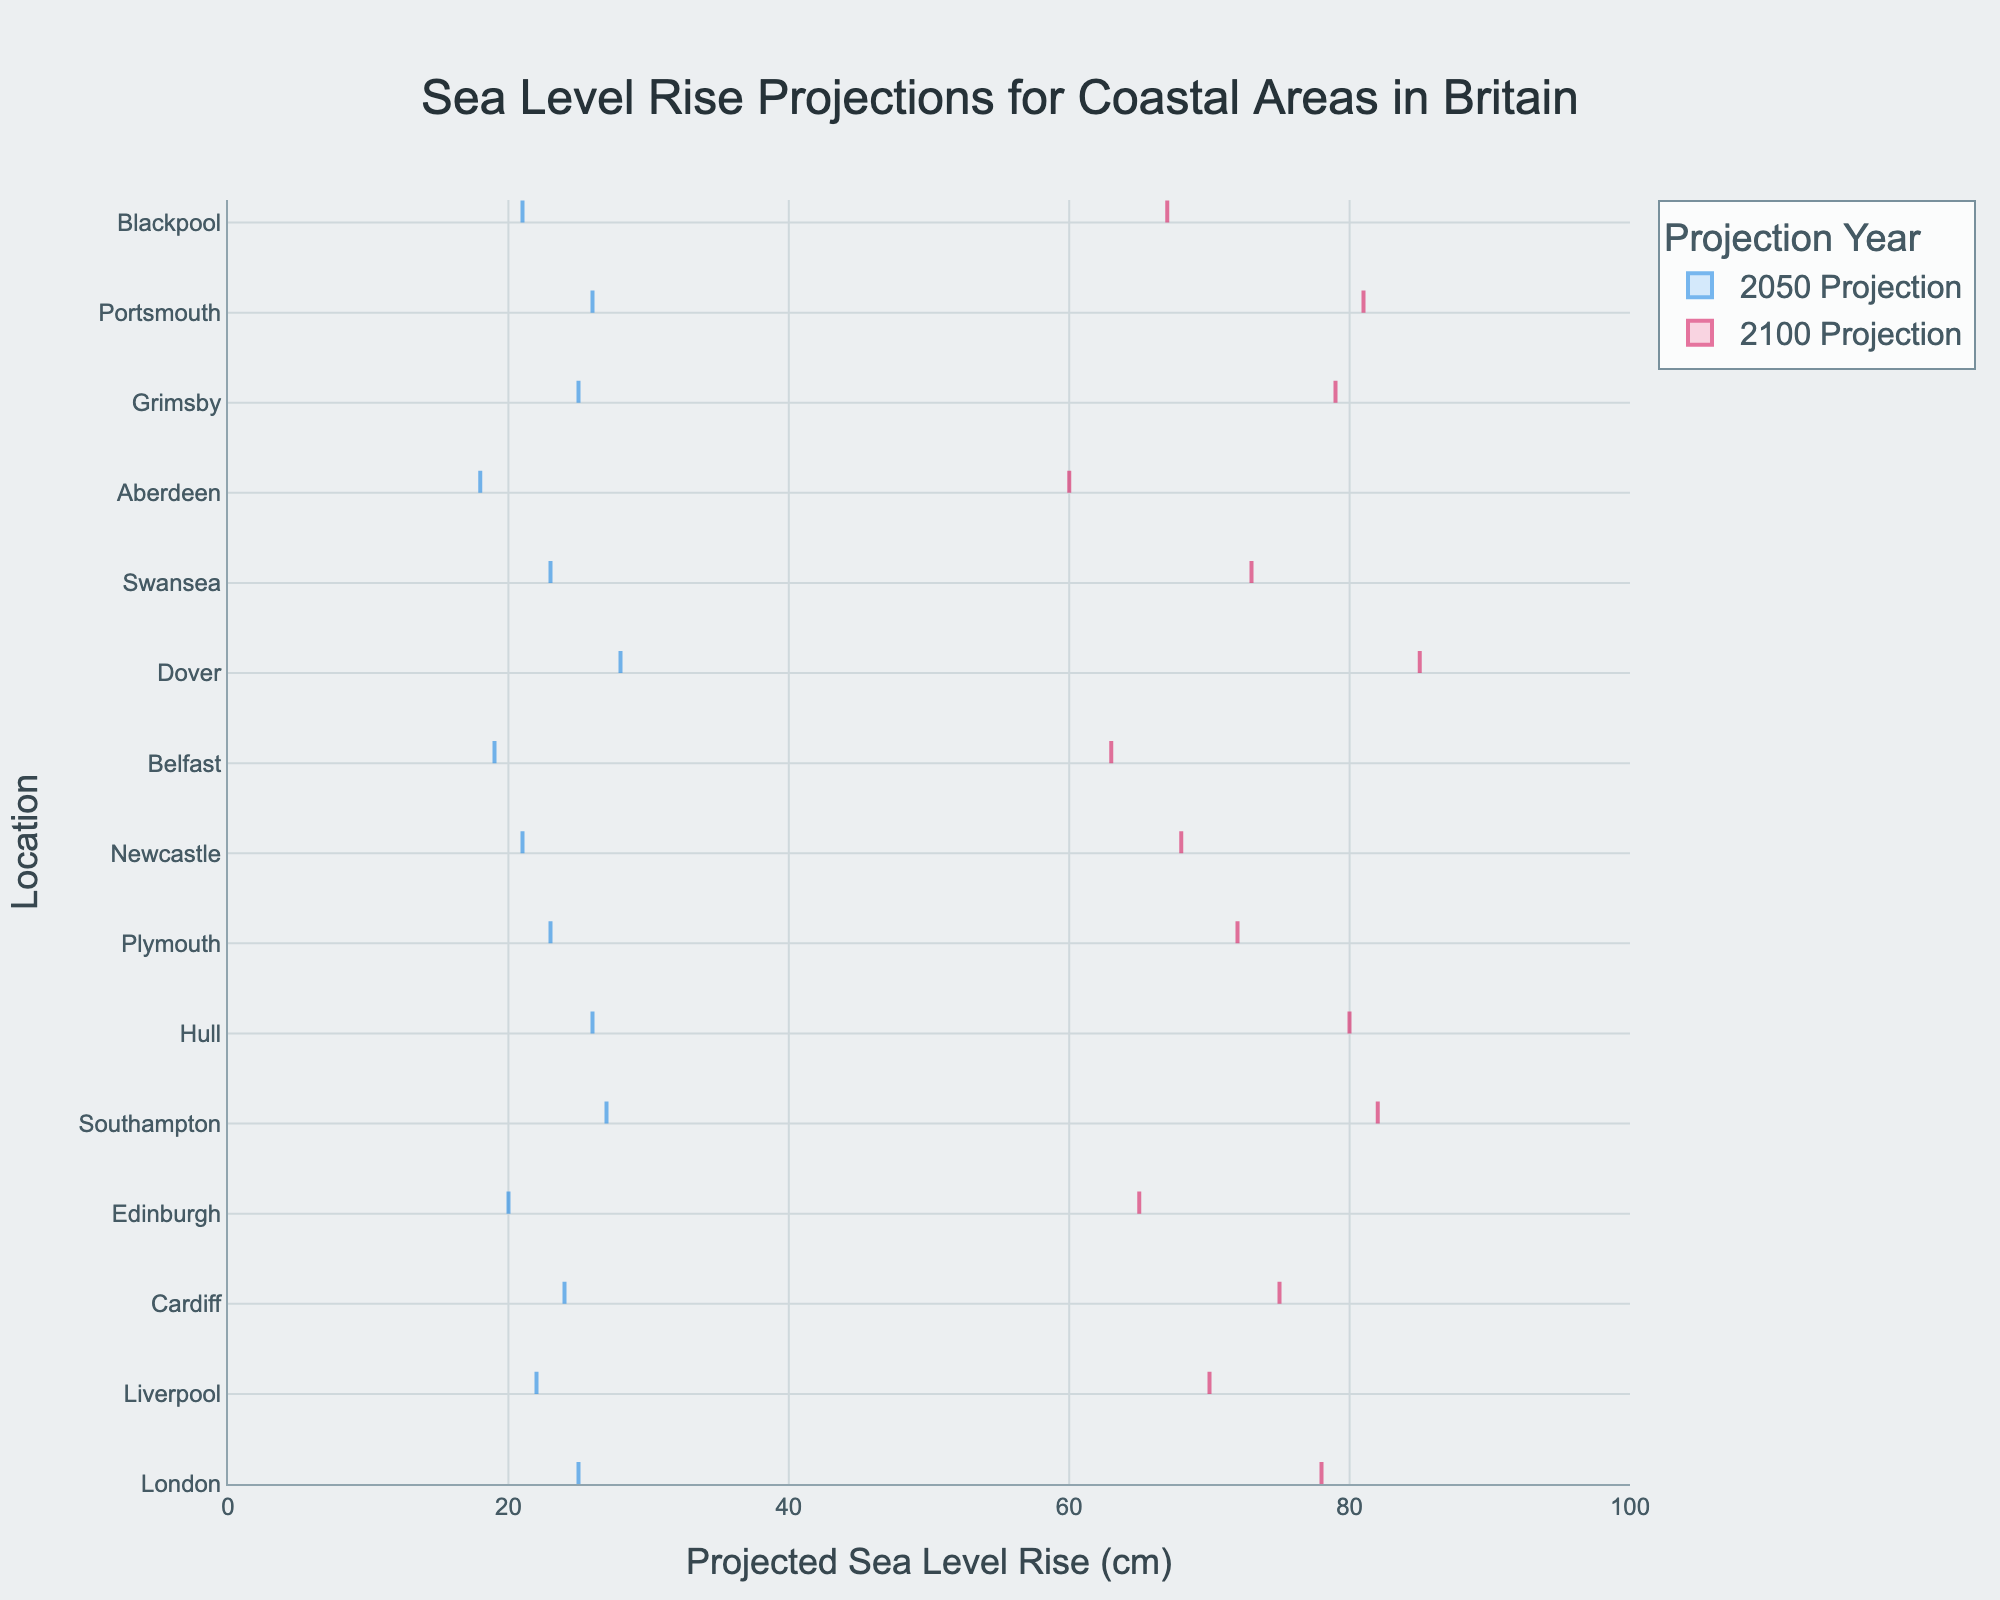What's the title of the figure? The title of the figure is prominently displayed at the top and is usually the most readable text element.
Answer: Sea Level Rise Projections for Coastal Areas in Britain Which year has the higher overall projections, 2050 or 2100? By visually comparing the densities of the projections for both years, you can see the 2100 projections generally extend further to the right than the 2050 projections.
Answer: 2100 What is the projected sea level rise for London in 2050 and 2100? Find London on the y-axis, then look at where the density plots for 2050 and 2100 intersect the x-axis. The values at these intersections represent the projections.
Answer: 25 cm (2050), 78 cm (2100) Which location has the highest projection for 2100? Locate the density plot that extends the furthest to the right for the 2100 projections. The corresponding y-axis label will be the location with the highest projection.
Answer: Dover How does the projection for Plymouth in 2050 compare to that for Liverpool in 2100? Find Plymouth and Liverpool on the y-axis and compare the x-axis values where their respective density plots for 2050 and 2100 intersect.
Answer: Plymouth's 2050 projection (23 cm) is lower than Liverpool's 2100 projection (70 cm) What's the difference between Edinburgh's projections for 2050 and 2100? Locate Edinburgh's projections on the density plots and subtract the 2050 projection from the 2100 projection.
Answer: 45 cm What's the range of sea level rise projections for Hull in 2050 and 2100 combined? Find Hull's projections on the density plots and identify the lowest (2050) and highest (2100) values.
Answer: 26 cm - 80 cm Which location shows the smallest increase from 2050 to 2100? Compare the increments by calculating the difference between the 2050 and 2100 projections for each location, and find the smallest one.
Answer: Aberdeen (42 cm) What is the median projection for 2050 across all locations? Organize the 2050 projections in ascending order and find the middle value. With 15 data points, the median is the 8th value in the sorted list.
Answer: 24 cm How does the projection for Cardiff in 2100 compare to Plymouth's projection for the same year? Locate Cardiff and Plymouth on the y-axis, then compare the x-axis values where their 2100 density plots intersect.
Answer: Cardiff's projection (75 cm) is slightly higher than Plymouth's (72 cm) 